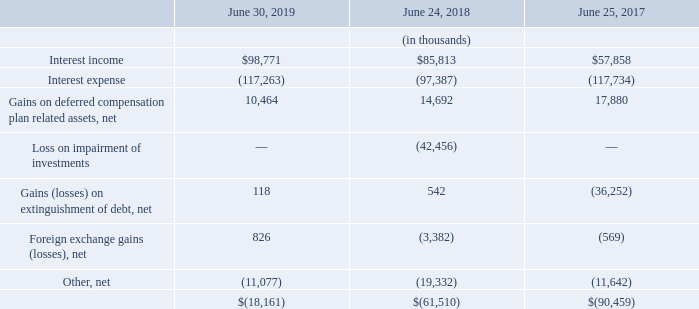Note 6: Other Expense, Net
The significant components of other expense, net, were as follows:
Interest income in the year ended June 30, 2019, increased compared to the years ended June 24, 2018, and June 25, 2017, primarily as a result of higher yield. Interest expense in the year ended June 30, 2019, increased compared to the year ended June 24, 2018, primarily due to issuance of the $2.5 billion of senior notes. Interest expense in the year ended June 24, 2018, decreased compared to the year ended June 25, 2017, primarily due to the conversions of 2018 and 2041 Convertible Notes as well as the retirement of the 2018 Convertible Notes in May 2018.
The gain on deferred compensation plan related assets in fiscal years 2019, 2018 and 2017 was driven by an improvement in the fair market value of the underlying funds.
The loss on impairment of investments in the year ended June 24, 2018 was the result of a decision to sell selected investments held in foreign jurisdictions in connection with the Company’s cash repatriation strategy following the December 2017 U.S. tax reform.
Net loss on extinguishment of debt realized in the year ended June 25, 2017, was primarily a result of the special mandatory redemption of the Senior Notes due 2023 and 2026, as well as the termination of the Term Loan Agreement.
What was the reason for the increase in interest income in 2019? Higher yield. What was the reason for the loss on impairment of investments in the year ended June 24, 2018? A decision to sell selected investments held in foreign jurisdictions in connection with the company’s cash repatriation strategy following the december 2017 u.s. tax reform. What were the reasons for the net loss on extinguishment of debt realized in the year ended June 25, 2017? The special mandatory redemption of the senior notes due 2023 and 2026, the termination of the term loan agreement. What is the percentage change in the interest income from 2018 to 2019?
Answer scale should be: percent. (98,771-85,813)/85,813
Answer: 15.1. What is the percentage change in the net gains on extinguishment of debt from 2018 to 2019?
Answer scale should be: percent. (118-542)/542
Answer: -78.23. What is the percentage change in the foreign exchange losses from 2017 to 2018?
Answer scale should be: percent. (3,382-569)/569
Answer: 494.38. 